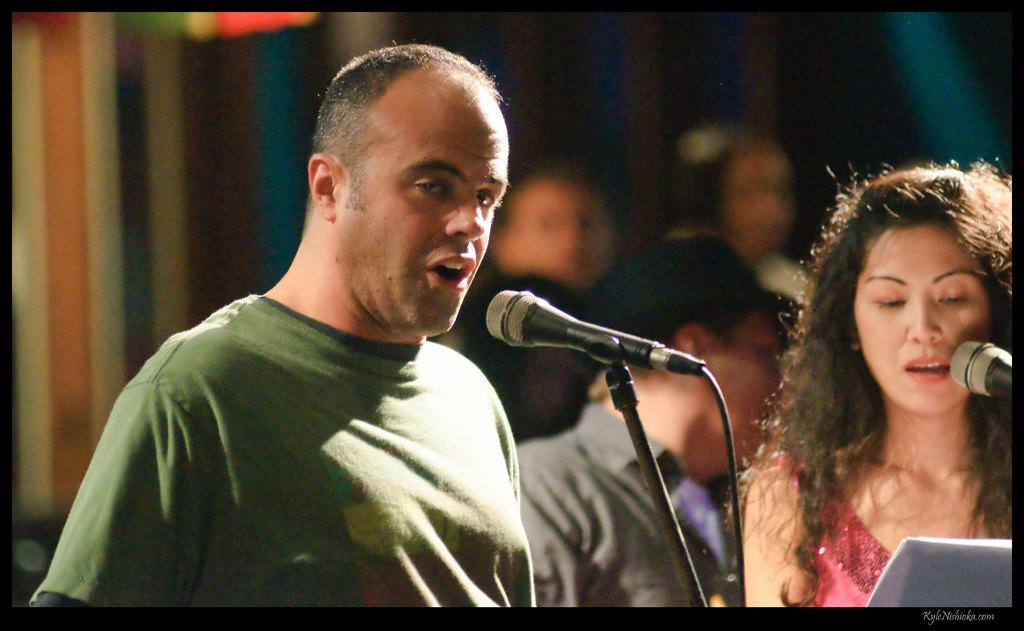What are the two persons in the foreground doing? The two persons in the foreground are singing. What object are they using while singing? They are in front of a microphone. What can be seen in the background of the image? There is a crowd and a curtain in the background. Where was the image taken? The image was taken on a stage. When did the event take place? The event took place during nighttime. What type of bulb is hanging from the branch in the image? There is no bulb or branch present in the image. How does the brain of the person on the left affect their singing performance? The image does not provide any information about the person's brain or its impact on their singing performance. 